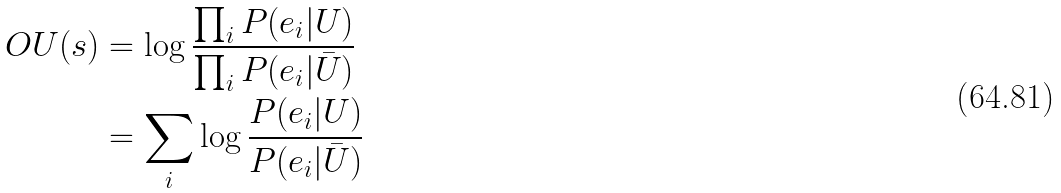<formula> <loc_0><loc_0><loc_500><loc_500>O U ( s ) & = \log { \frac { \prod _ { i } P ( e _ { i } | U ) } { \prod _ { i } P ( e _ { i } | \bar { U } ) } } \\ & = \sum _ { i } \log { \frac { P ( e _ { i } | U ) } { P ( e _ { i } | \bar { U } ) } }</formula> 